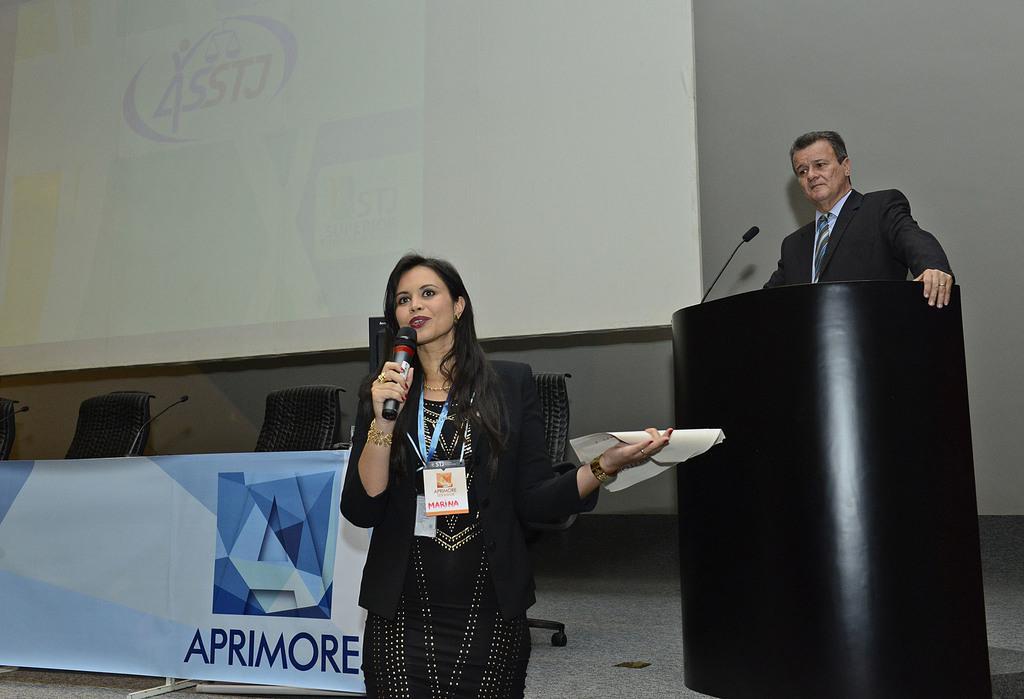In one or two sentences, can you explain what this image depicts? In the center of the image we an see a woman holding the mike and also the paper and standing. In the background we can see the stage with a man standing in front of the podium and also mike. We can also see the chairs, miles, a banner with text. We can also see the display screen and also the plain wall. 